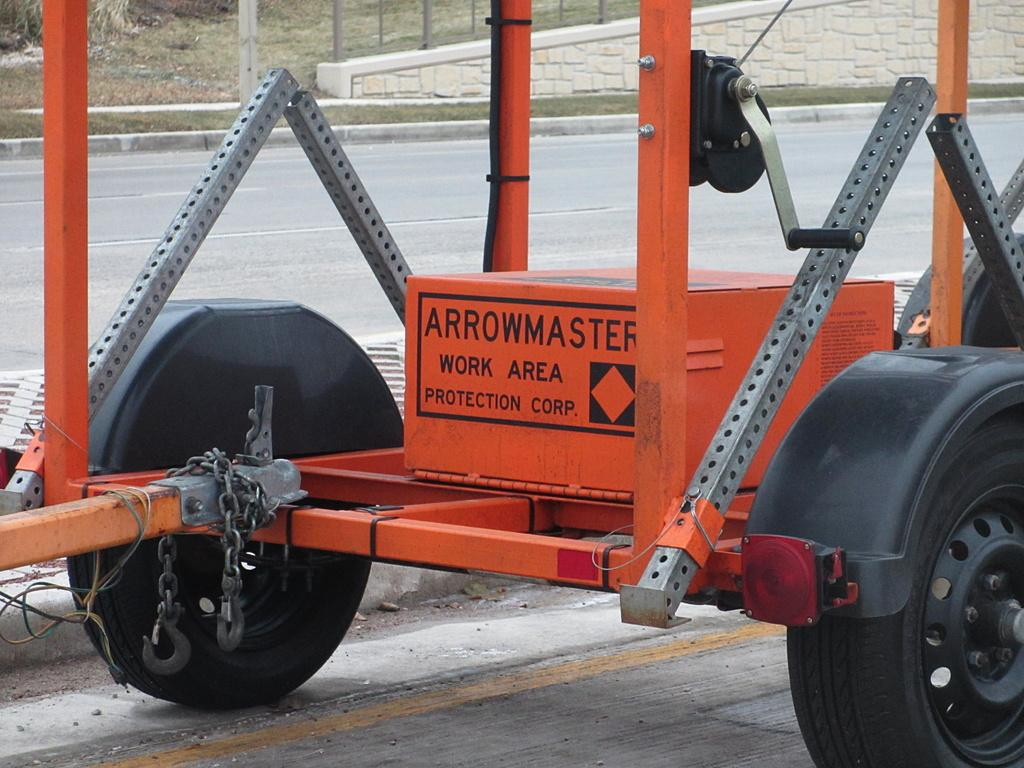What is the main subject of the image? There is a vehicle on the road in the image. What can be seen in the background of the image? There are poles, a wall, and grass in the background of the image. How does the desire for the ocean affect the elbow in the image? There is no mention of desire or the ocean in the image, and therefore no such effect on the elbow can be observed. 